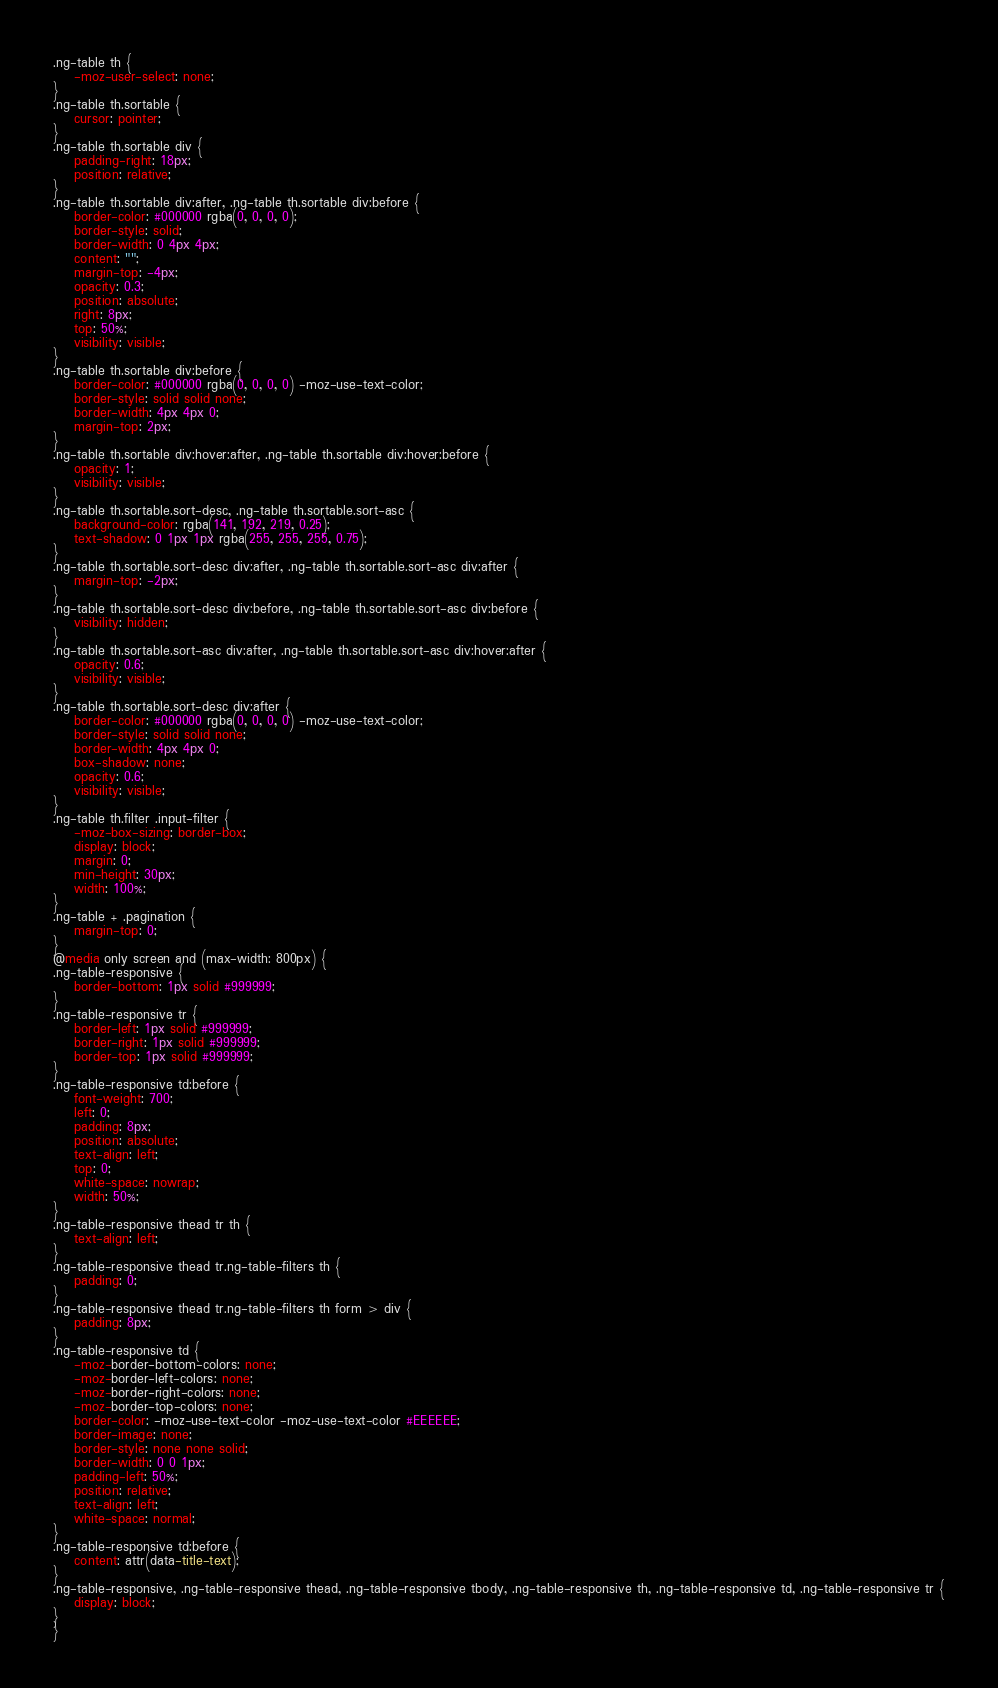Convert code to text. <code><loc_0><loc_0><loc_500><loc_500><_CSS_>
.ng-table th {
    -moz-user-select: none;
}
.ng-table th.sortable {
    cursor: pointer;
}
.ng-table th.sortable div {
    padding-right: 18px;
    position: relative;
}
.ng-table th.sortable div:after, .ng-table th.sortable div:before {
    border-color: #000000 rgba(0, 0, 0, 0);
    border-style: solid;
    border-width: 0 4px 4px;
    content: "";
    margin-top: -4px;
    opacity: 0.3;
    position: absolute;
    right: 8px;
    top: 50%;
    visibility: visible;
}
.ng-table th.sortable div:before {
    border-color: #000000 rgba(0, 0, 0, 0) -moz-use-text-color;
    border-style: solid solid none;
    border-width: 4px 4px 0;
    margin-top: 2px;
}
.ng-table th.sortable div:hover:after, .ng-table th.sortable div:hover:before {
    opacity: 1;
    visibility: visible;
}
.ng-table th.sortable.sort-desc, .ng-table th.sortable.sort-asc {
    background-color: rgba(141, 192, 219, 0.25);
    text-shadow: 0 1px 1px rgba(255, 255, 255, 0.75);
}
.ng-table th.sortable.sort-desc div:after, .ng-table th.sortable.sort-asc div:after {
    margin-top: -2px;
}
.ng-table th.sortable.sort-desc div:before, .ng-table th.sortable.sort-asc div:before {
    visibility: hidden;
}
.ng-table th.sortable.sort-asc div:after, .ng-table th.sortable.sort-asc div:hover:after {
    opacity: 0.6;
    visibility: visible;
}
.ng-table th.sortable.sort-desc div:after {
    border-color: #000000 rgba(0, 0, 0, 0) -moz-use-text-color;
    border-style: solid solid none;
    border-width: 4px 4px 0;
    box-shadow: none;
    opacity: 0.6;
    visibility: visible;
}
.ng-table th.filter .input-filter {
    -moz-box-sizing: border-box;
    display: block;
    margin: 0;
    min-height: 30px;
    width: 100%;
}
.ng-table + .pagination {
    margin-top: 0;
}
@media only screen and (max-width: 800px) {
.ng-table-responsive {
    border-bottom: 1px solid #999999;
}
.ng-table-responsive tr {
    border-left: 1px solid #999999;
    border-right: 1px solid #999999;
    border-top: 1px solid #999999;
}
.ng-table-responsive td:before {
    font-weight: 700;
    left: 0;
    padding: 8px;
    position: absolute;
    text-align: left;
    top: 0;
    white-space: nowrap;
    width: 50%;
}
.ng-table-responsive thead tr th {
    text-align: left;
}
.ng-table-responsive thead tr.ng-table-filters th {
    padding: 0;
}
.ng-table-responsive thead tr.ng-table-filters th form > div {
    padding: 8px;
}
.ng-table-responsive td {
    -moz-border-bottom-colors: none;
    -moz-border-left-colors: none;
    -moz-border-right-colors: none;
    -moz-border-top-colors: none;
    border-color: -moz-use-text-color -moz-use-text-color #EEEEEE;
    border-image: none;
    border-style: none none solid;
    border-width: 0 0 1px;
    padding-left: 50%;
    position: relative;
    text-align: left;
    white-space: normal;
}
.ng-table-responsive td:before {
    content: attr(data-title-text);
}
.ng-table-responsive, .ng-table-responsive thead, .ng-table-responsive tbody, .ng-table-responsive th, .ng-table-responsive td, .ng-table-responsive tr {
    display: block;
}
}
</code> 